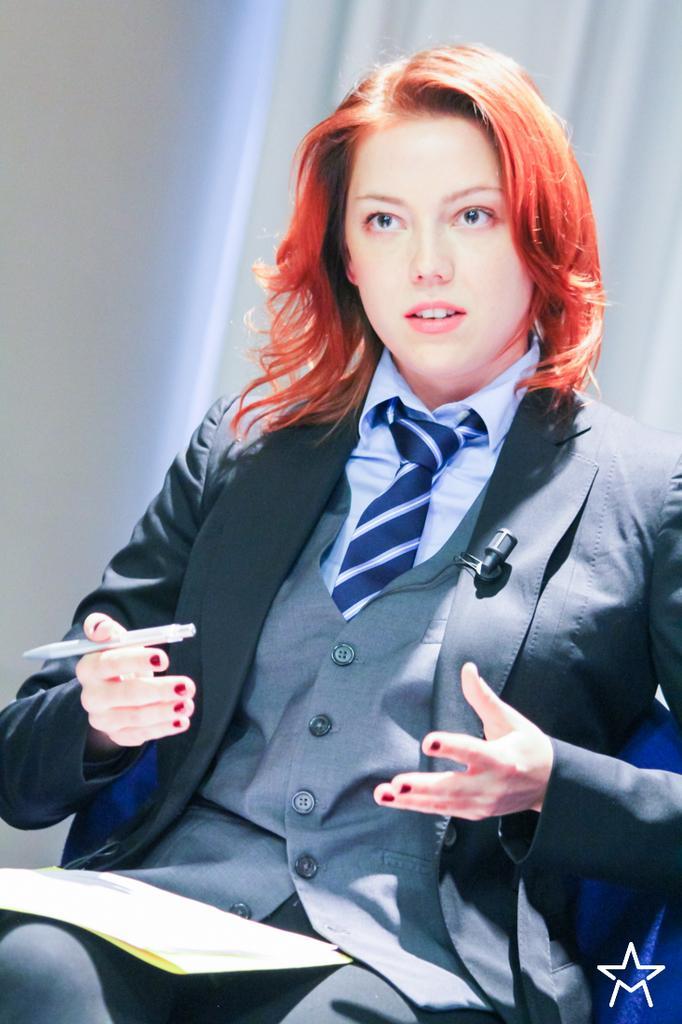How would you summarize this image in a sentence or two? In this picture we can see a woman sitting on the chair. She is holding a pen and kept papers on her lap. There is a wall and a white curtain in the background. 